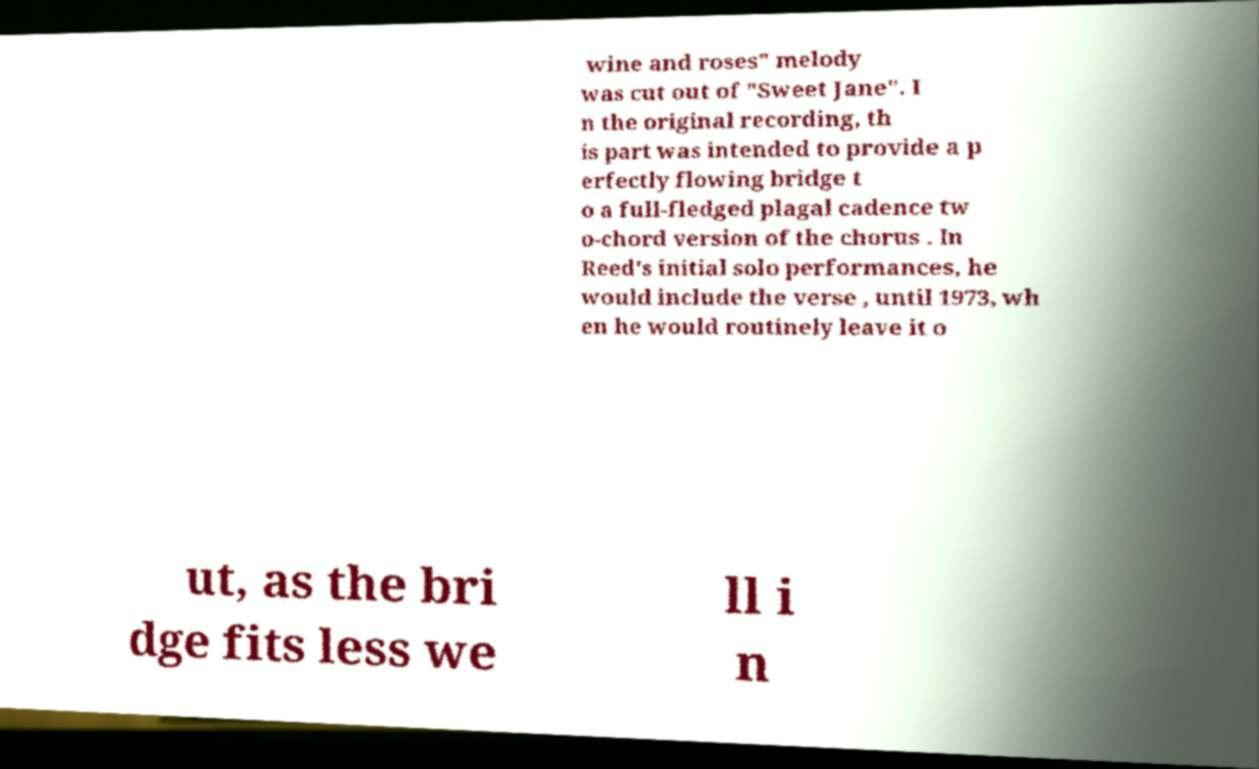Can you read and provide the text displayed in the image?This photo seems to have some interesting text. Can you extract and type it out for me? wine and roses" melody was cut out of "Sweet Jane". I n the original recording, th is part was intended to provide a p erfectly flowing bridge t o a full-fledged plagal cadence tw o-chord version of the chorus . In Reed's initial solo performances, he would include the verse , until 1973, wh en he would routinely leave it o ut, as the bri dge fits less we ll i n 